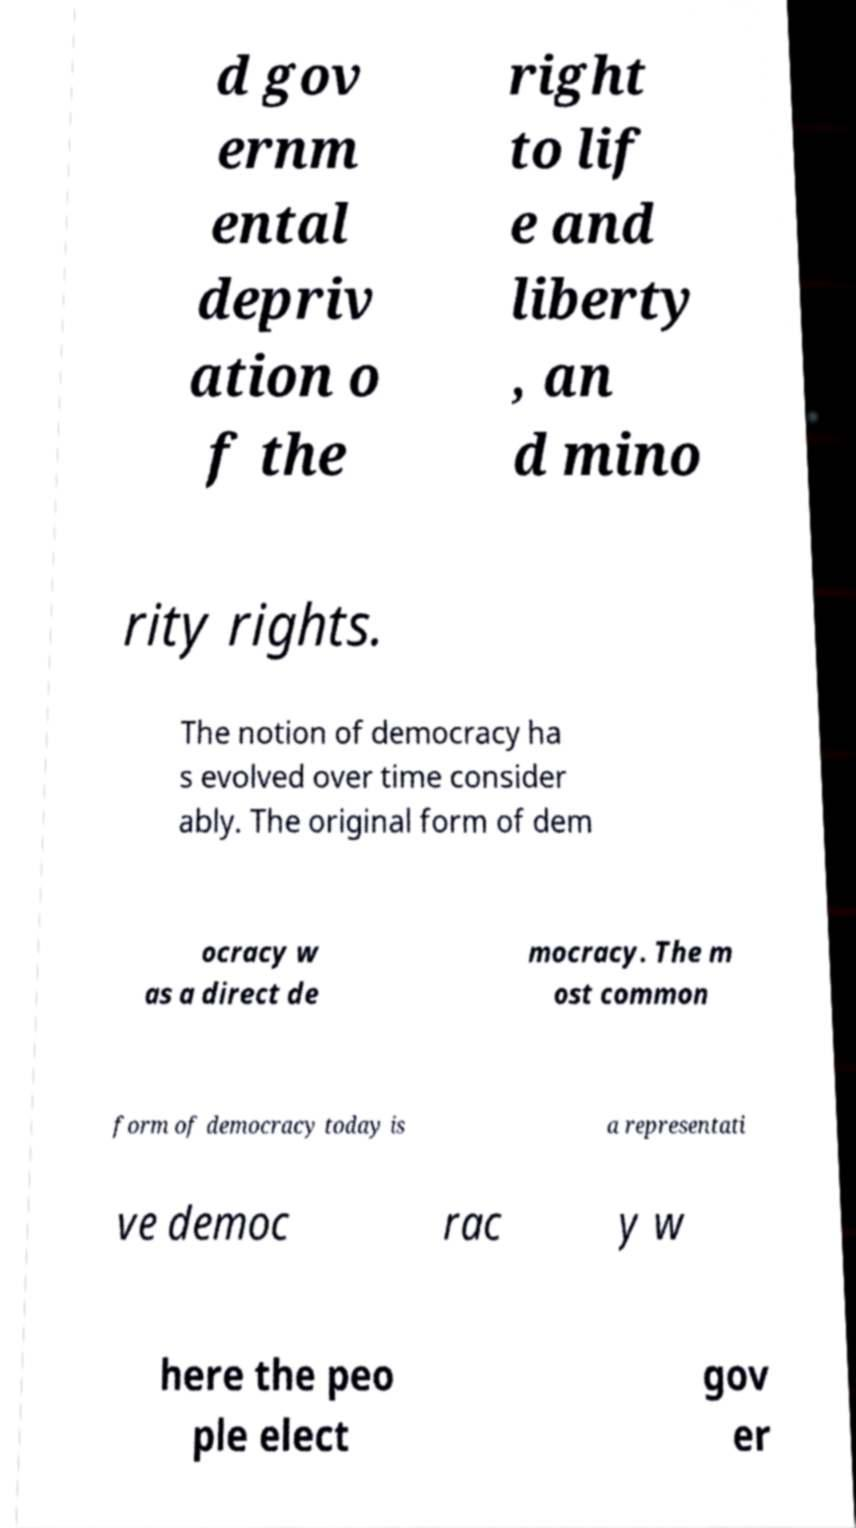For documentation purposes, I need the text within this image transcribed. Could you provide that? d gov ernm ental depriv ation o f the right to lif e and liberty , an d mino rity rights. The notion of democracy ha s evolved over time consider ably. The original form of dem ocracy w as a direct de mocracy. The m ost common form of democracy today is a representati ve democ rac y w here the peo ple elect gov er 